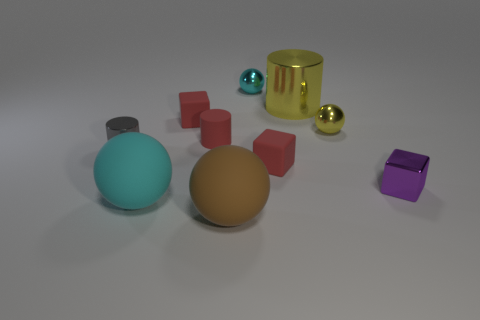There is a tiny thing that is the same color as the big metallic thing; what is it made of?
Ensure brevity in your answer.  Metal. What shape is the purple thing that is the same material as the gray cylinder?
Your answer should be very brief. Cube. Is the number of tiny purple metallic blocks in front of the large yellow cylinder greater than the number of cyan matte spheres that are behind the large cyan object?
Make the answer very short. Yes. How many things are metallic cylinders or tiny purple metallic cubes?
Offer a terse response. 3. How many other objects are the same color as the large shiny cylinder?
Make the answer very short. 1. There is a cyan metallic object that is the same size as the purple cube; what shape is it?
Provide a succinct answer. Sphere. The matte block on the right side of the brown thing is what color?
Make the answer very short. Red. How many objects are rubber things that are in front of the gray metal thing or small red matte cubes to the left of the big brown object?
Your answer should be very brief. 4. Do the brown rubber thing and the gray metallic cylinder have the same size?
Give a very brief answer. No. What number of cylinders are either big brown things or small purple metallic objects?
Keep it short and to the point. 0. 